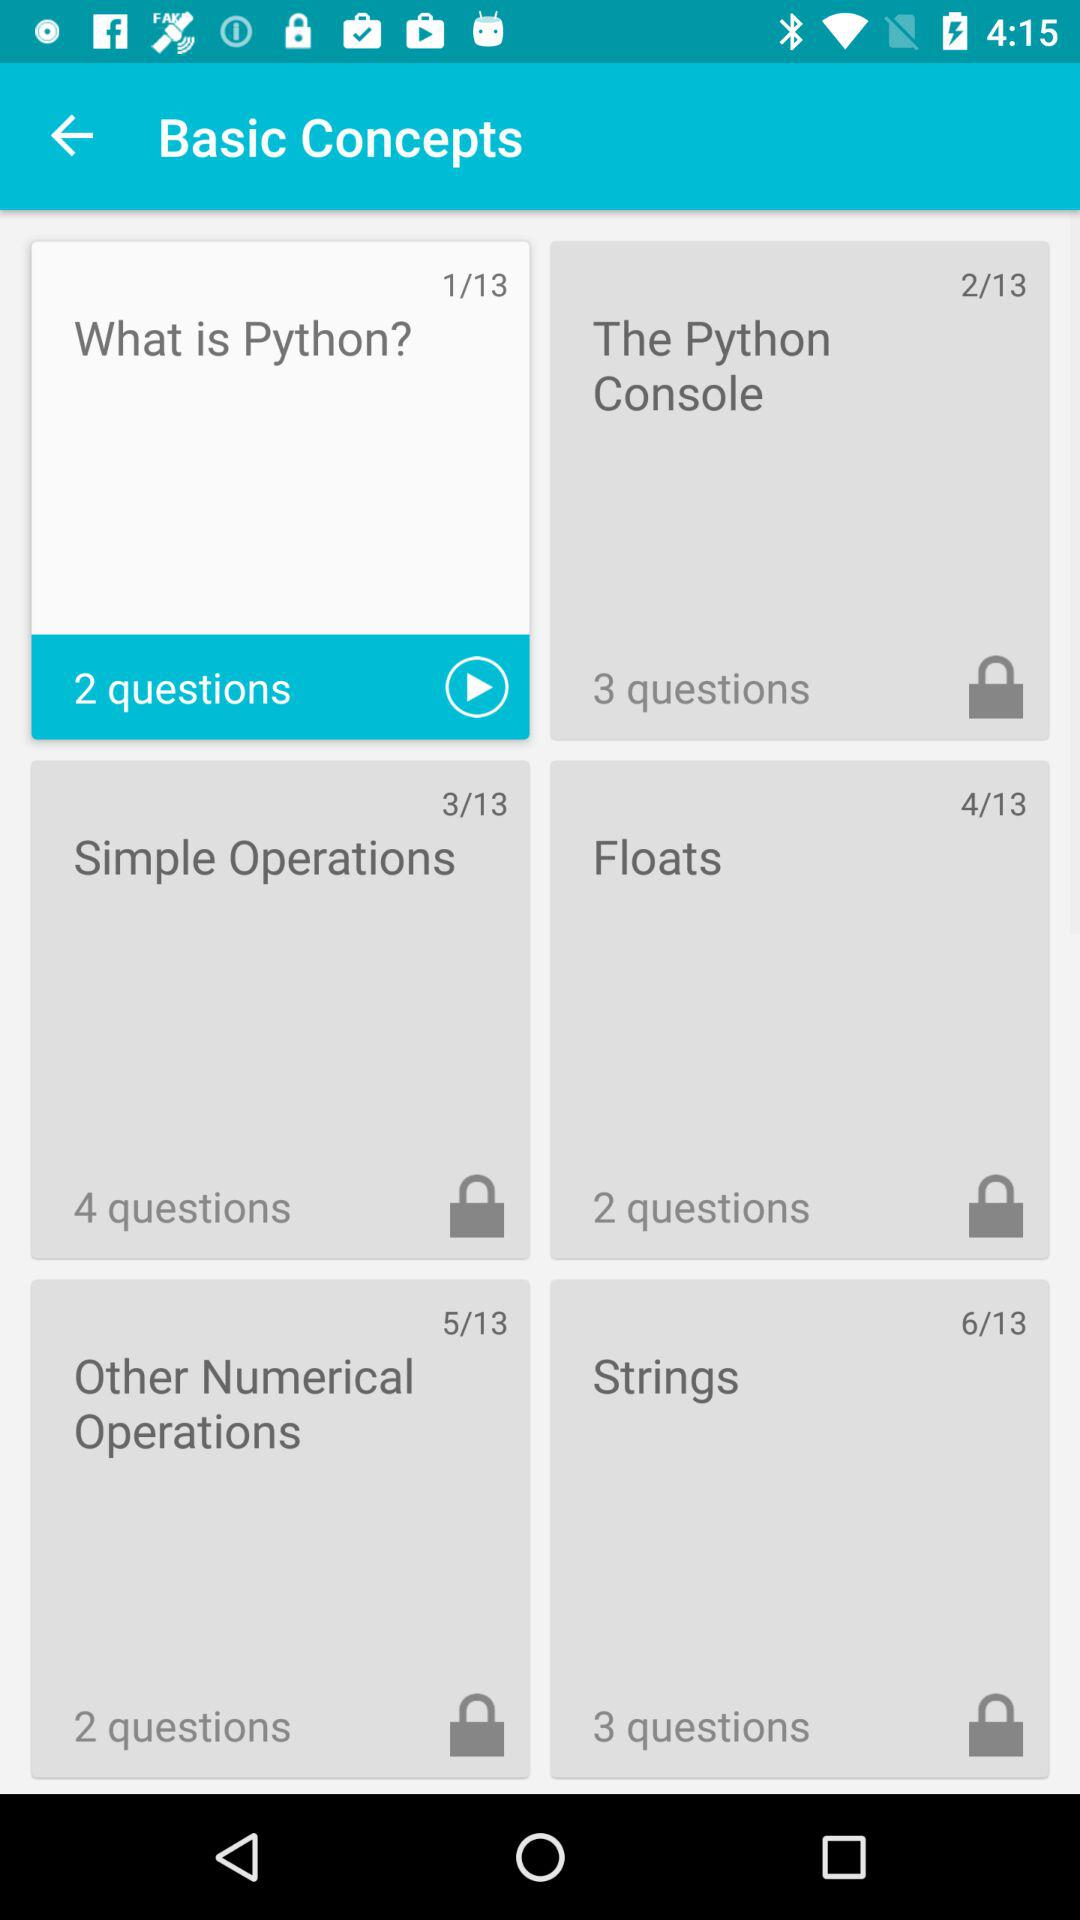What is the total number of slides? The total number of slides is 13. 